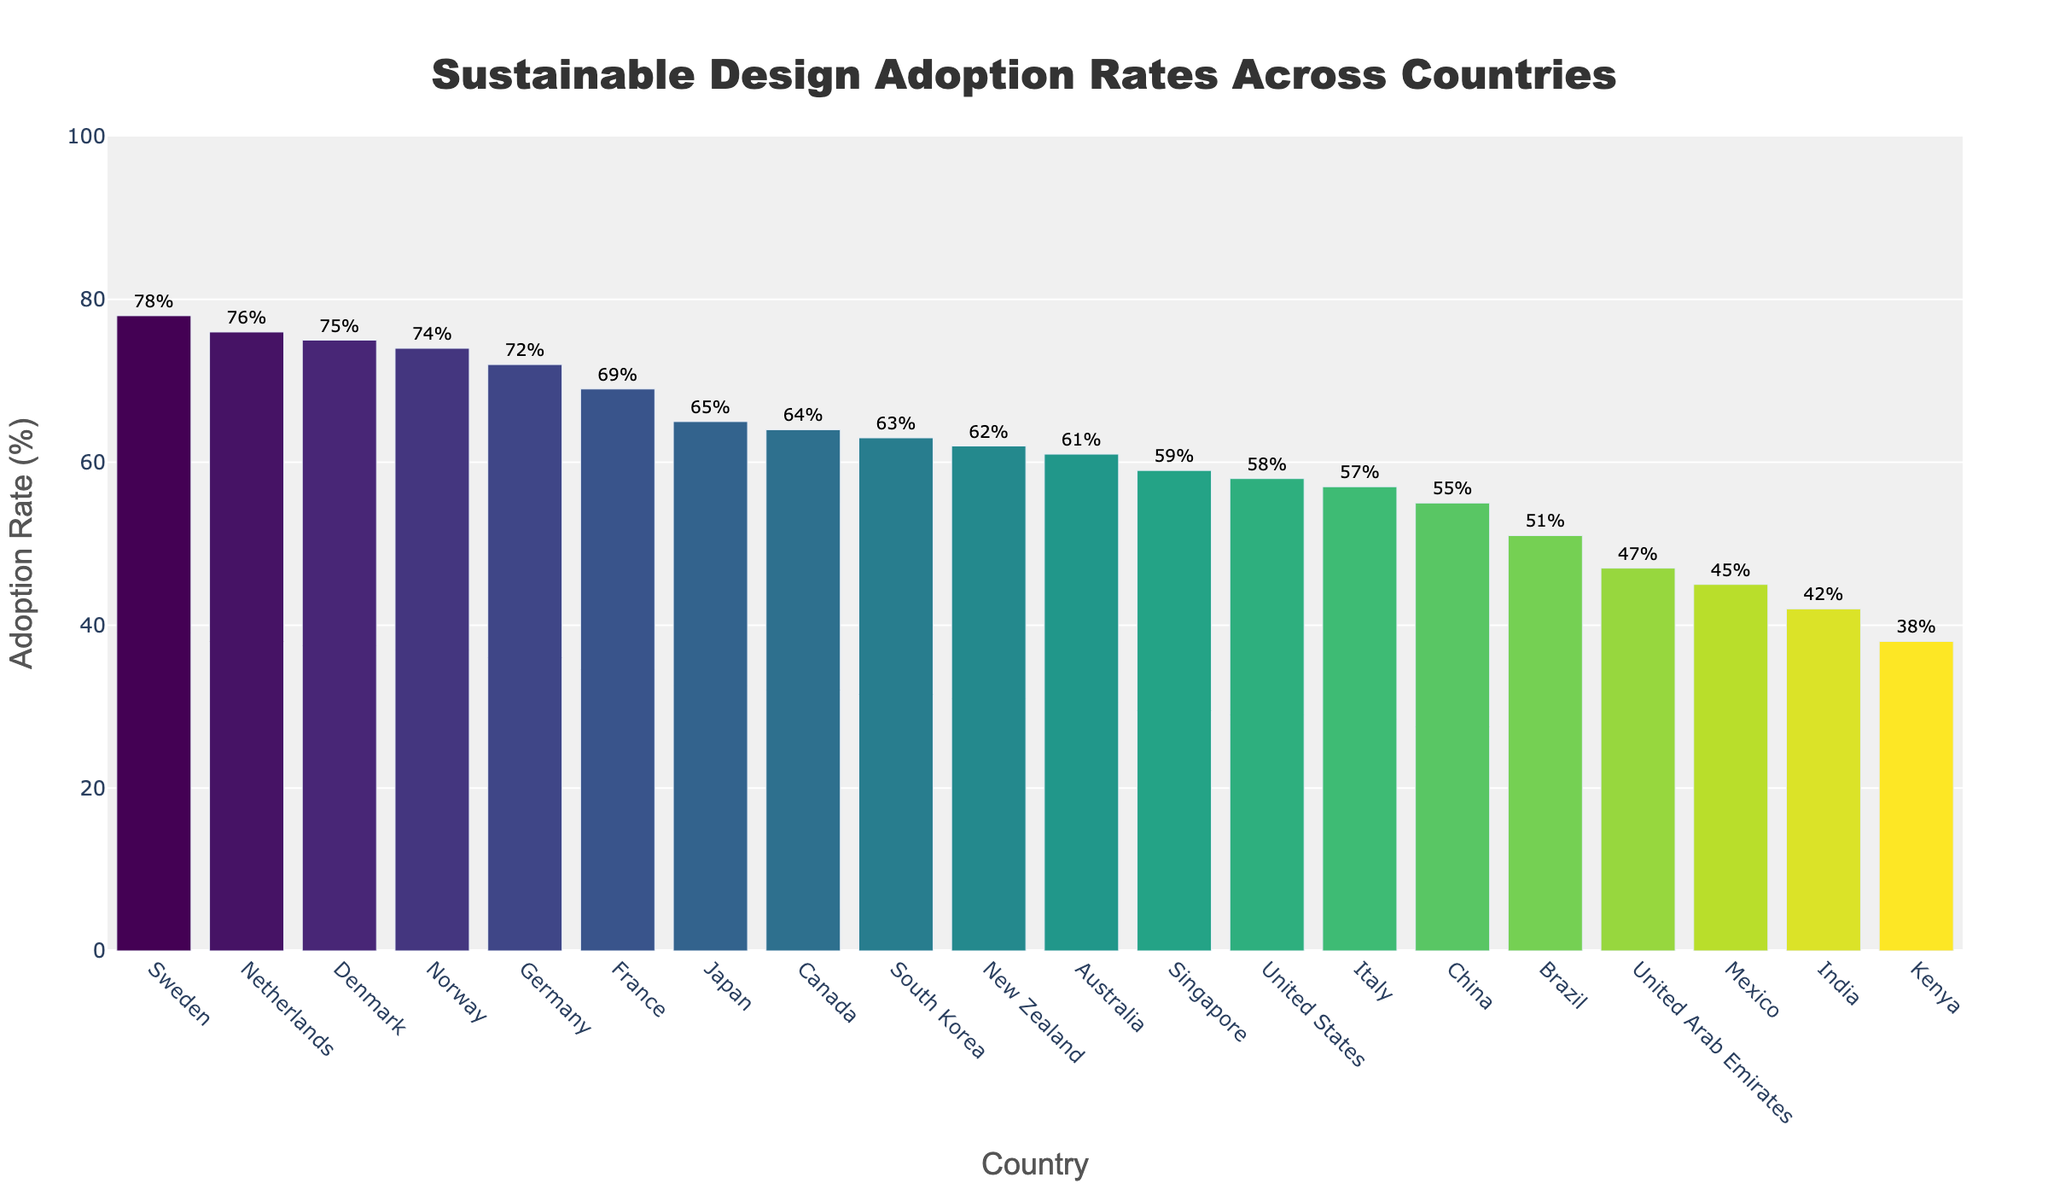Which country has the highest adoption rate of sustainable design practices? The highest bar on the chart represents Sweden, which visually shows the highest percentage of 78%.
Answer: Sweden What is the difference in adoption rates between the country with the highest rate and the country with the lowest rate? The highest adoption rate is Sweden at 78%, and the lowest is Kenya at 38%. The difference is 78% - 38% = 40%.
Answer: 40% Which three countries have the top adoption rates of sustainable design practices? The highlighted top three bars represent Sweden (78%), Netherlands (76%), and Denmark (75%).
Answer: Sweden, Netherlands, Denmark Is the adoption rate of sustainable design practices for the United States higher or lower than Canada? According to the chart, the adoption rate for the United States is 58%, while for Canada, it is 64%. Thus, the United States has a lower adoption rate than Canada.
Answer: Lower What is the average adoption rate of sustainable design practices for Germany, Japan, and France? The adoption rates are Germany 72%, Japan 65%, and France 69%. The average is (72 + 65 + 69) / 3 = 68.67%.
Answer: 68.67% Which country has an adoption rate closest to 60%? The chart shows that Singapore has an adoption rate of 59%, which is the closest to 60%.
Answer: Singapore How many countries have an adoption rate of 70% or higher? By counting the bars above 70%, we see five countries: Sweden, Netherlands, Denmark, Germany, and Norway.
Answer: 5 Which two countries have nearly equal adoption rates around 42-45%? The countries in the range of 42-45% are India (42%) and Mexico (45%), which are fairly close in their adoption rates.
Answer: India, Mexico Compare the adoption rates of South Korea and Australia. Which country has a higher rate and by how much? South Korea's adoption rate is 63%, and Australia's is 61%. South Korea's rate is higher by 63% - 61% = 2%.
Answer: South Korea; 2% What is the combined adoption rate of the highlighted top three countries? The adoption rates for Sweden, Netherlands, and Denmark are 78%, 76%, and 75%, respectively. The combined rate is 78% + 76% + 75% = 229%.
Answer: 229% 